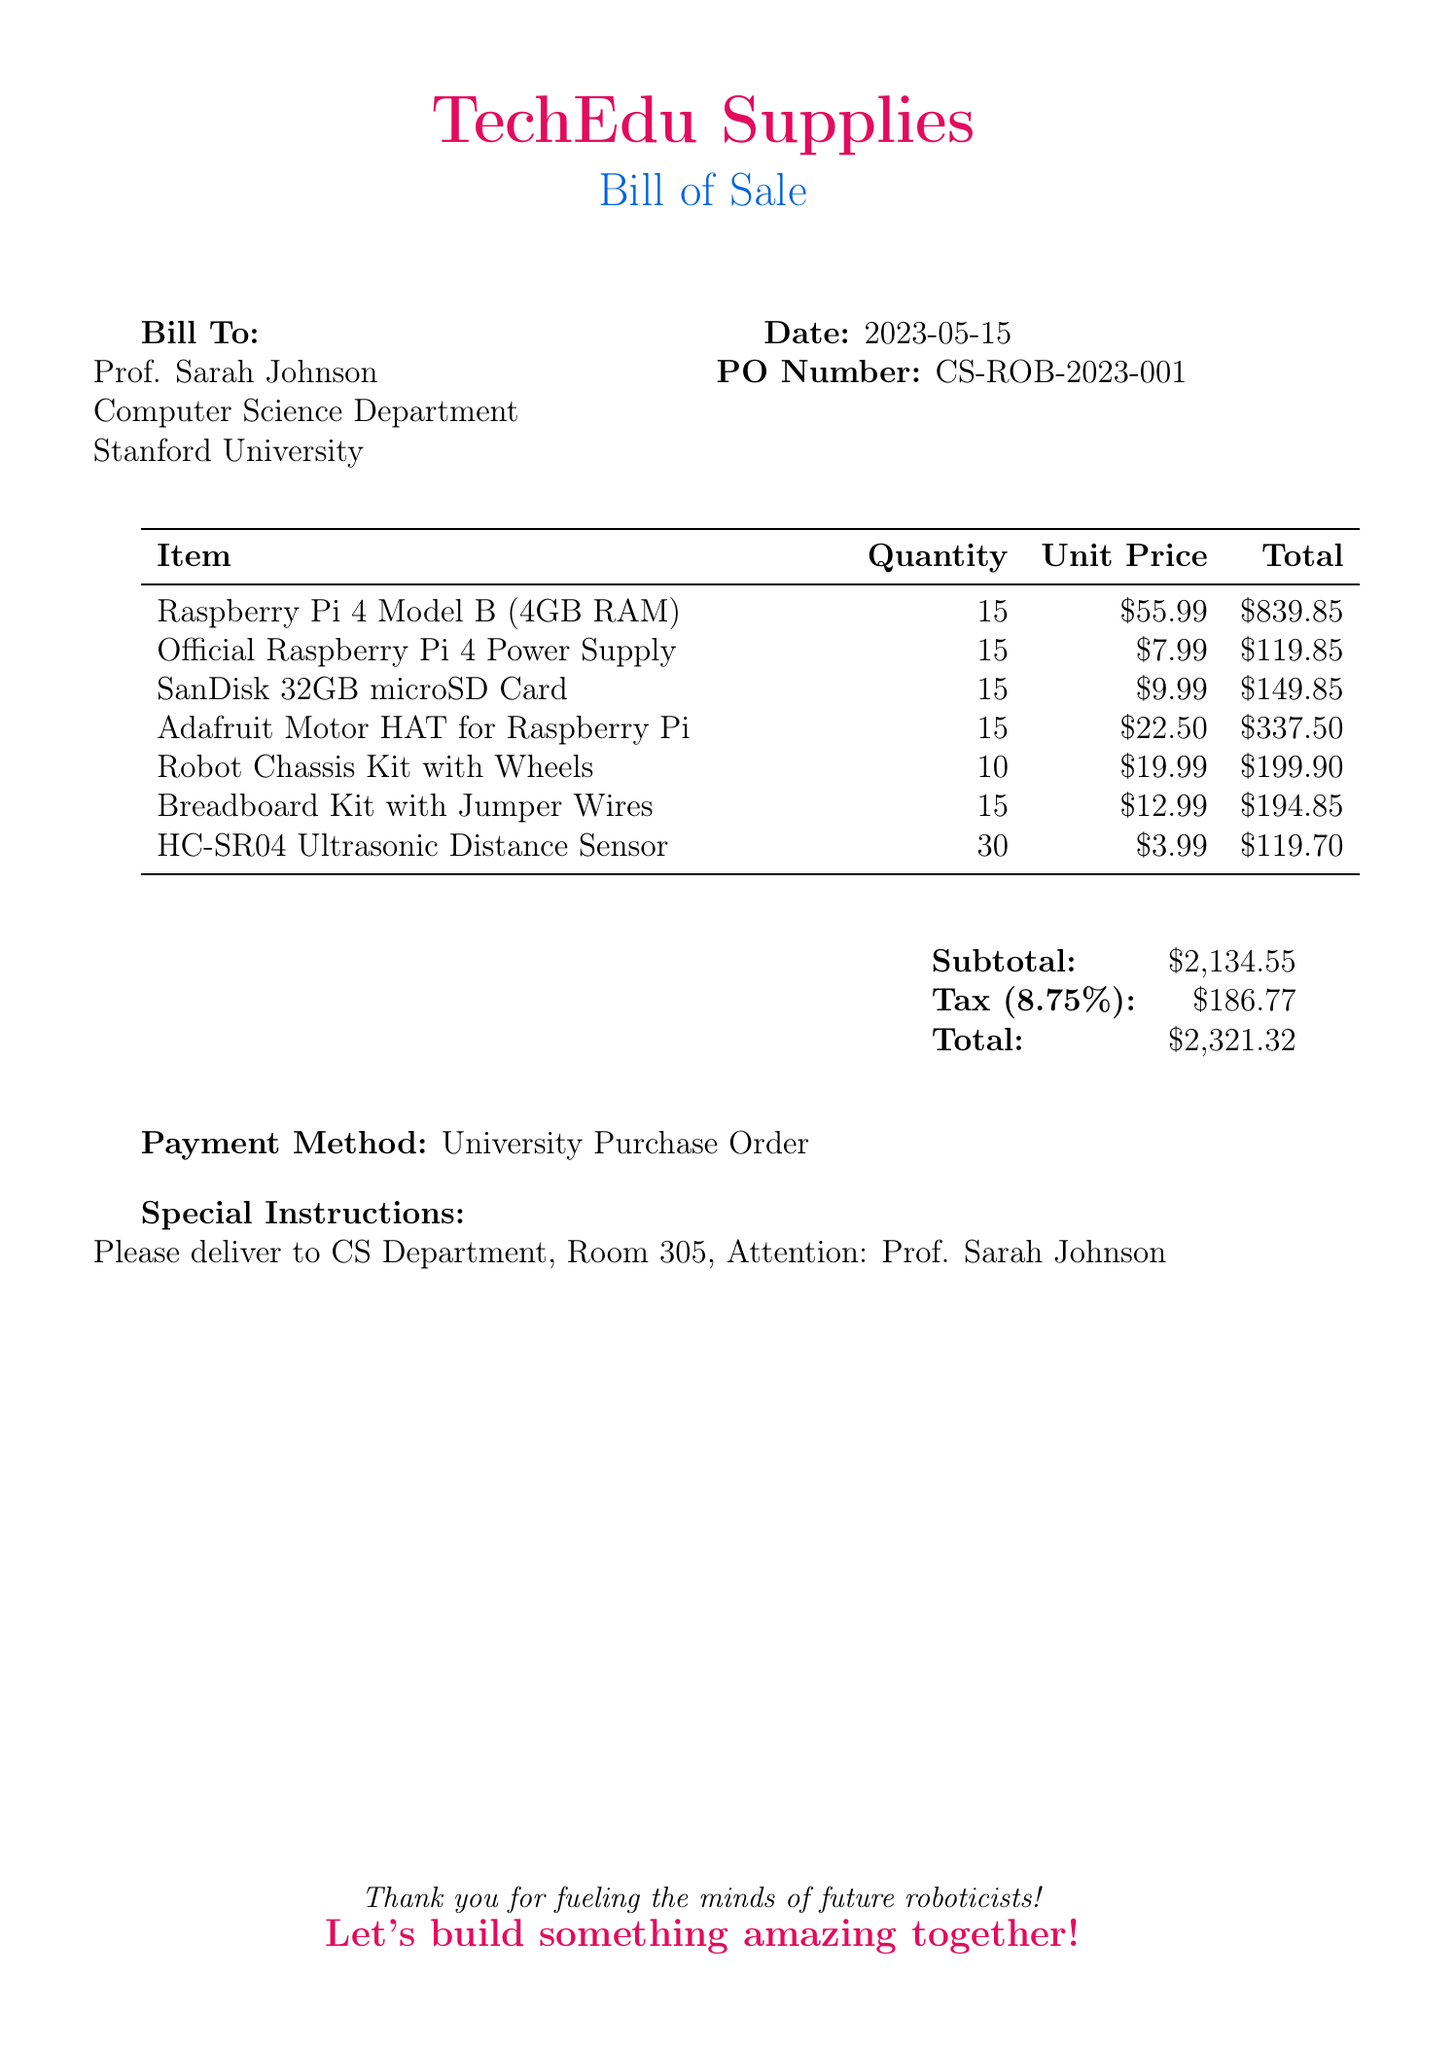What is the date of the bill? The date is explicitly mentioned in the document under the date section, which is 2023-05-15.
Answer: 2023-05-15 Who is the recipient of the bill? The document specifies the recipient's name as Prof. Sarah Johnson in the "Bill To" section.
Answer: Prof. Sarah Johnson What is the total amount due? The total amount due is found in the summary section at the bottom of the document, labeled "Total."
Answer: $2,321.32 How many Raspberry Pi kits were purchased? The quantity of Raspberry Pi kits is listed in the item section, specifically against the Raspberry Pi 4 Model B entry.
Answer: 15 What is the unit price of the Adafruit Motor HAT? The unit price is given in the item section under the specific entry for the Adafruit Motor HAT for Raspberry Pi.
Answer: $22.50 What payment method is listed on the bill? The payment method is mentioned at the bottom of the document as a university purchase order.
Answer: University Purchase Order How many HC-SR04 Ultrasonic Distance Sensors were purchased? The number of sensors is indicated in the item list side by side with their description.
Answer: 30 What is the subtotal before tax? The subtotal is explicitly stated in the financial summary section of the document.
Answer: $2,134.55 What are the special instructions for delivery? The special instructions are included in the document, specifying where the items should be delivered.
Answer: Please deliver to CS Department, Room 305, Attention: Prof. Sarah Johnson 